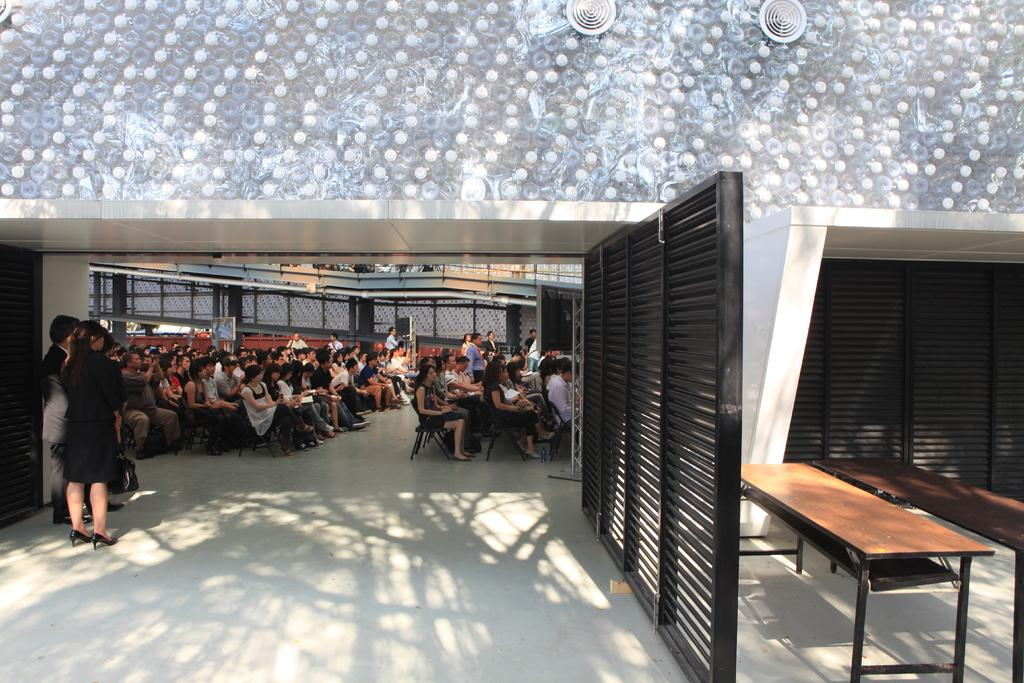How many people are in the image? There is a group of persons in the image. What are the people in the image doing? Some of the persons are sitting, while others are standing. What can be seen on the right side of the image? There is a stand on the right side of the image. What is the color of the stand? The stand is black in color. What type of furniture is present in the image? There are tables in the image. What type of potato is being sold at the shop in the image? There is no shop present in the image, and therefore no potato can be observed being sold. How do the people in the image express disgust? There is no indication of disgust in the image; the people are simply sitting or standing. 